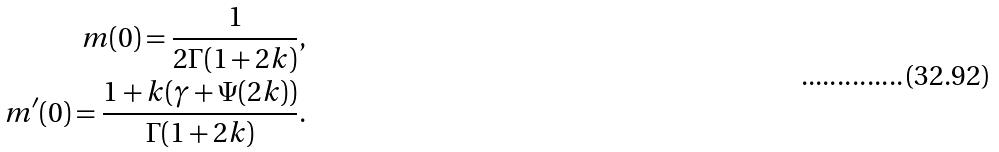Convert formula to latex. <formula><loc_0><loc_0><loc_500><loc_500>m ( 0 ) = \frac { 1 } { 2 \Gamma ( 1 + 2 k ) } , \\ m ^ { \prime } ( 0 ) = \frac { 1 + k ( \gamma + \Psi ( 2 k ) ) } { \Gamma ( 1 + 2 k ) } .</formula> 